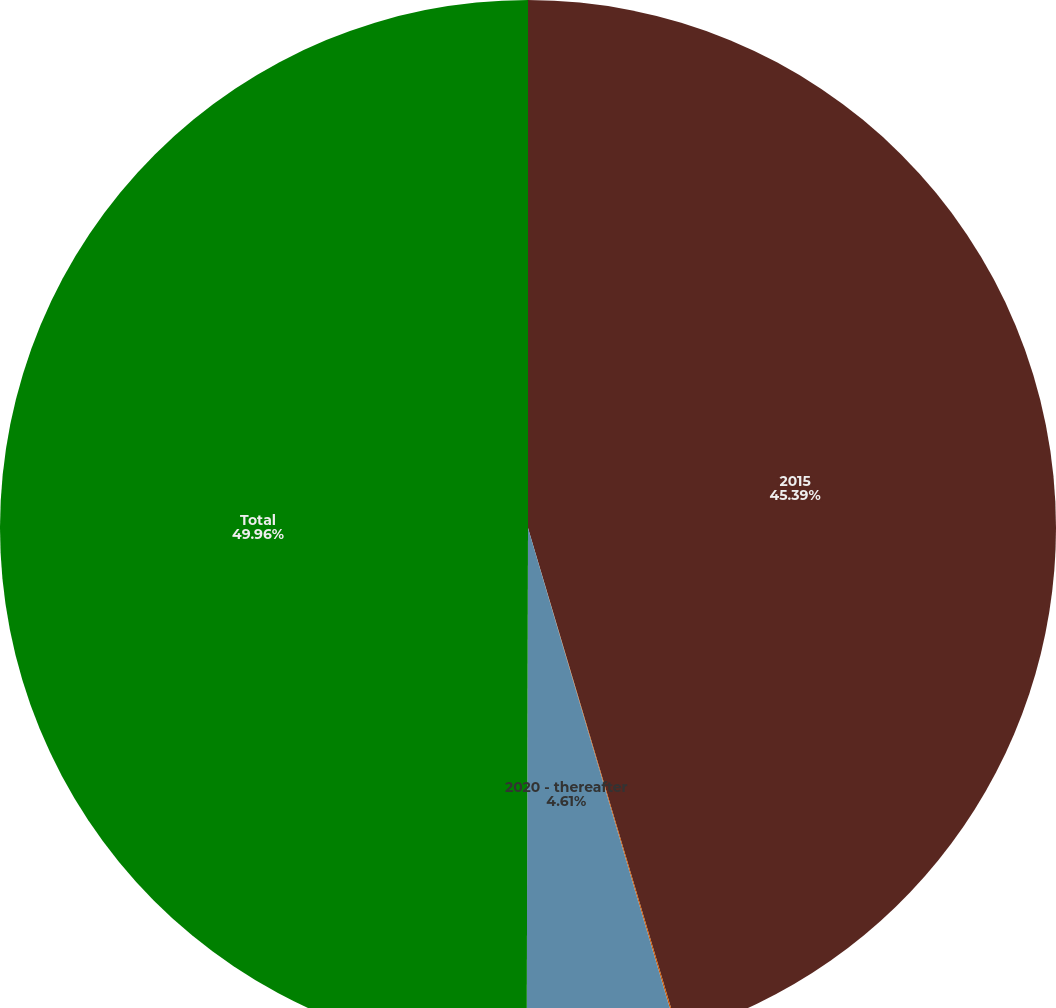<chart> <loc_0><loc_0><loc_500><loc_500><pie_chart><fcel>2015<fcel>2016<fcel>2020 - thereafter<fcel>Total<nl><fcel>45.39%<fcel>0.04%<fcel>4.61%<fcel>49.96%<nl></chart> 